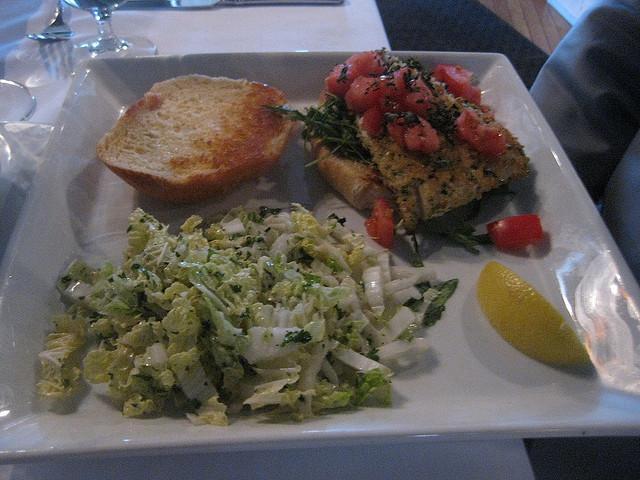How many pieces is the sandwich cut into?
Give a very brief answer. 1. How many sandwiches are in the photo?
Give a very brief answer. 2. 